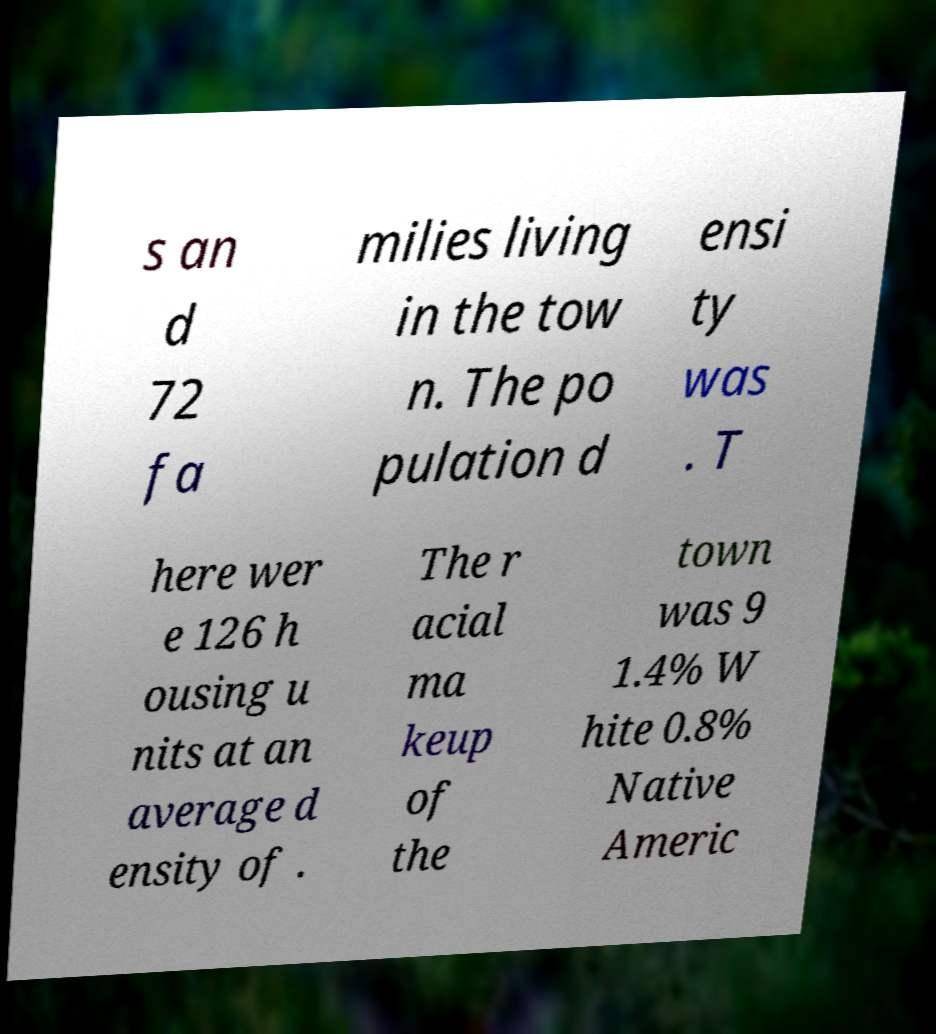Can you read and provide the text displayed in the image?This photo seems to have some interesting text. Can you extract and type it out for me? s an d 72 fa milies living in the tow n. The po pulation d ensi ty was . T here wer e 126 h ousing u nits at an average d ensity of . The r acial ma keup of the town was 9 1.4% W hite 0.8% Native Americ 